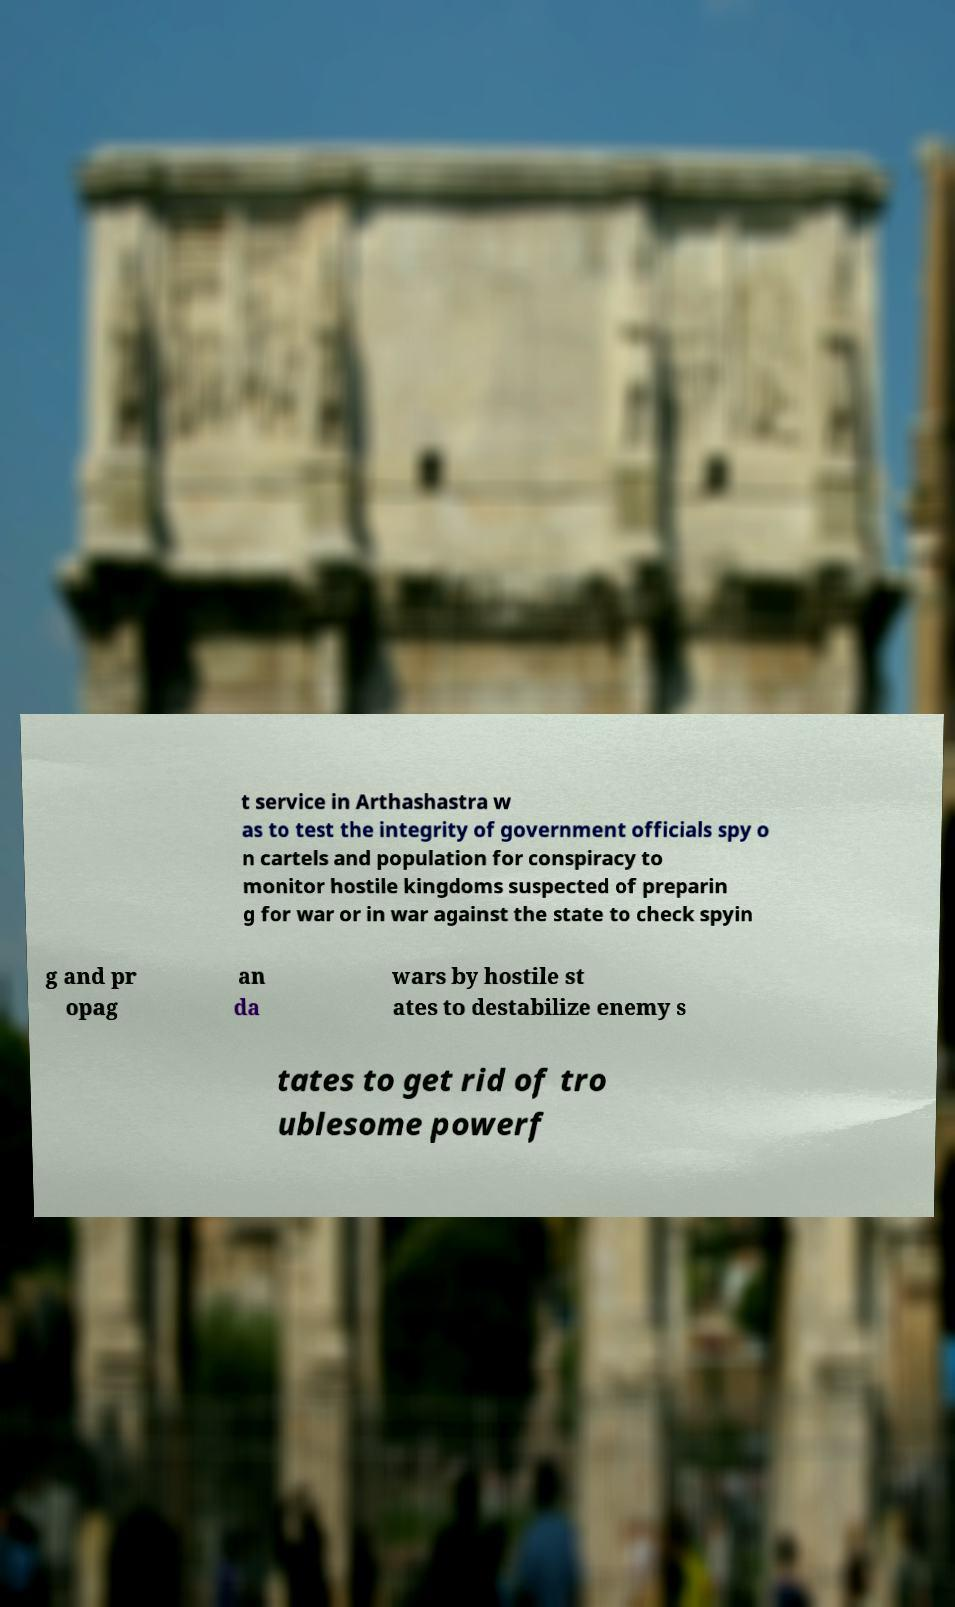I need the written content from this picture converted into text. Can you do that? t service in Arthashastra w as to test the integrity of government officials spy o n cartels and population for conspiracy to monitor hostile kingdoms suspected of preparin g for war or in war against the state to check spyin g and pr opag an da wars by hostile st ates to destabilize enemy s tates to get rid of tro ublesome powerf 